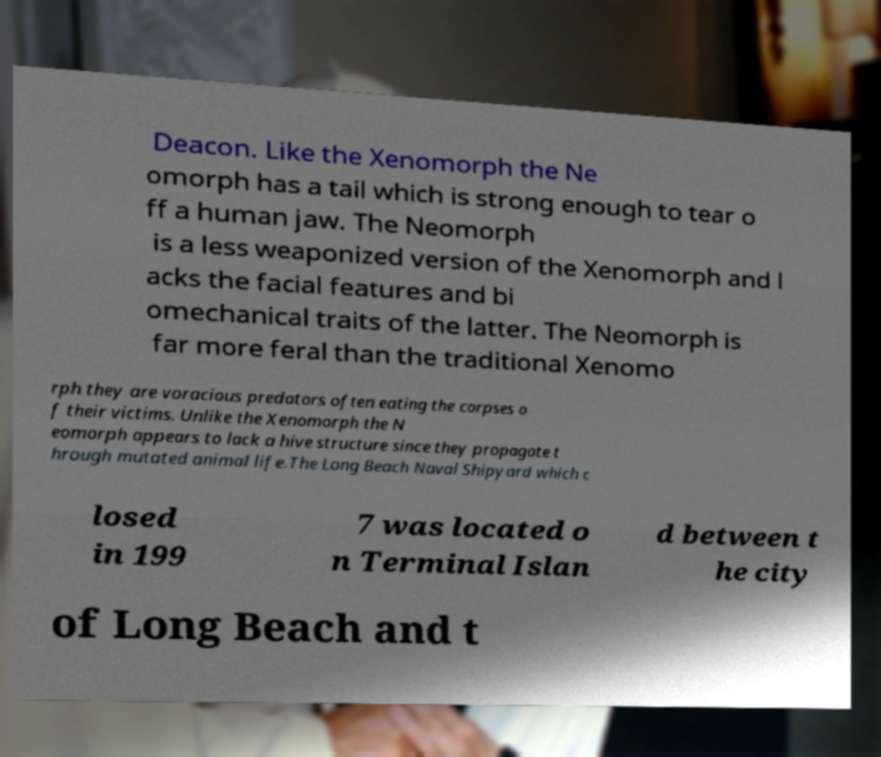Could you assist in decoding the text presented in this image and type it out clearly? Deacon. Like the Xenomorph the Ne omorph has a tail which is strong enough to tear o ff a human jaw. The Neomorph is a less weaponized version of the Xenomorph and l acks the facial features and bi omechanical traits of the latter. The Neomorph is far more feral than the traditional Xenomo rph they are voracious predators often eating the corpses o f their victims. Unlike the Xenomorph the N eomorph appears to lack a hive structure since they propagate t hrough mutated animal life.The Long Beach Naval Shipyard which c losed in 199 7 was located o n Terminal Islan d between t he city of Long Beach and t 